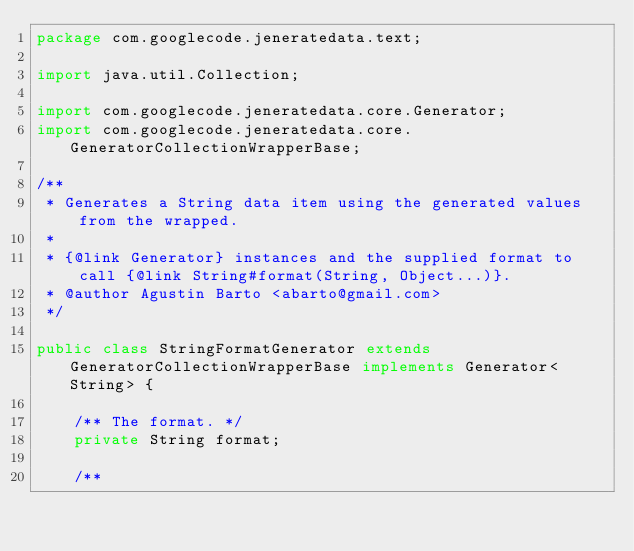<code> <loc_0><loc_0><loc_500><loc_500><_Java_>package com.googlecode.jeneratedata.text;

import java.util.Collection;

import com.googlecode.jeneratedata.core.Generator;
import com.googlecode.jeneratedata.core.GeneratorCollectionWrapperBase;

/**
 * Generates a String data item using the generated values from the wrapped.
 *
 * {@link Generator} instances and the supplied format to call {@link String#format(String, Object...)}.
 * @author Agustin Barto <abarto@gmail.com>
 */

public class StringFormatGenerator extends GeneratorCollectionWrapperBase implements Generator<String> {
	
	/** The format. */
	private String format;
	
	/**</code> 